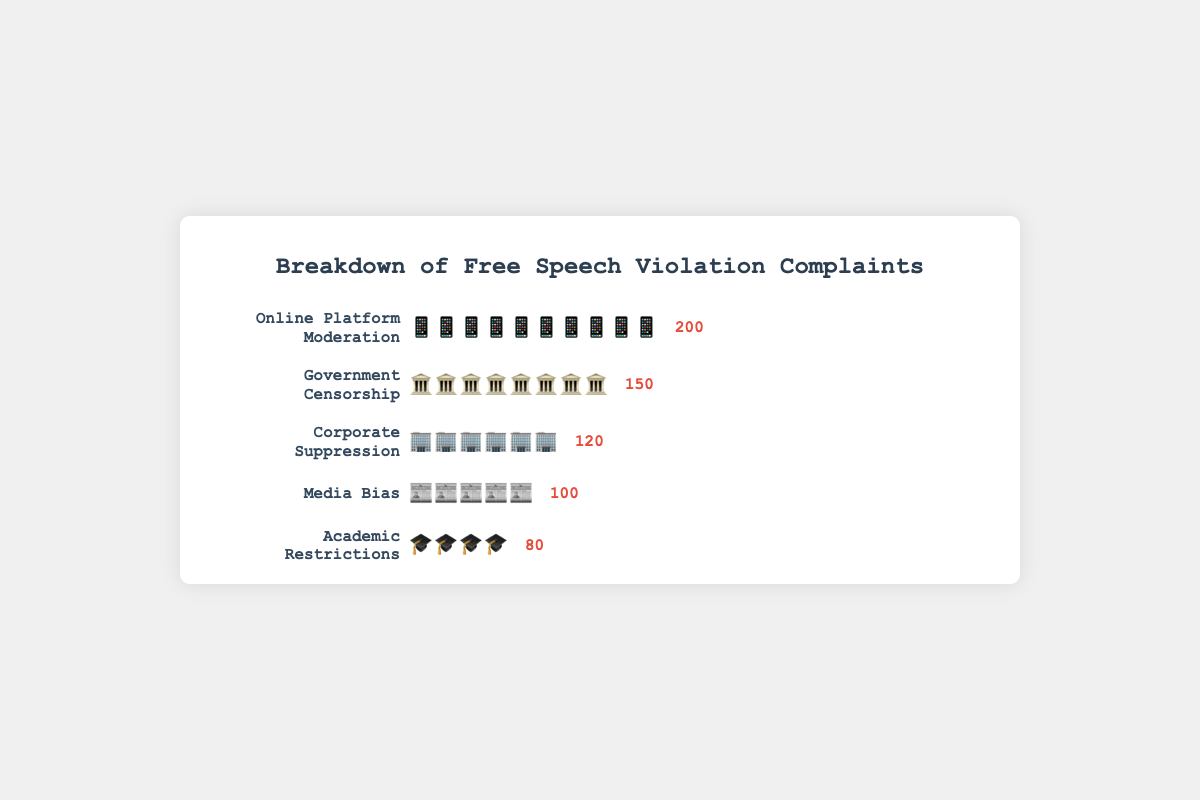Which category has the highest number of complaints? Look at the counts associated with each category. The highest number is 200, which corresponds to Online Platform Moderation
Answer: Online Platform Moderation How many more complaints are there about Government Censorship compared to Academic Restrictions? Subtract the number of complaints for Academic Restrictions (80) from the number of complaints for Government Censorship (150). The calculation is 150 - 80 = 70
Answer: 70 What is the total number of complaints across all categories? Add the complaint counts for all categories: 150 (Government Censorship) + 120 (Corporate Suppression) + 80 (Academic Restrictions) + 200 (Online Platform Moderation) + 100 (Media Bias). The calculation is 150 + 120 + 80 + 200 + 100 = 650
Answer: 650 Which category has the fewest complaints? Look at the counts associated with each category. The fewest number is 80, which corresponds to Academic Restrictions
Answer: Academic Restrictions What is the average number of complaints per category? Calculate the total number of complaints, 650, and divide it by the number of categories, 5. The calculation is 650 / 5 = 130
Answer: 130 How does the number of complaints about Corporate Suppression compare to Media Bias? Compare the counts: Corporate Suppression has 120 complaints, and Media Bias has 100 complaints. Therefore, Corporate Suppression has 20 more complaints.
Answer: 20 more complaints If the complaints are ranked by count, which category is third? Rank the categories by their counts: 1. Online Platform Moderation (200), 2. Government Censorship (150), 3. Corporate Suppression (120), 4. Media Bias (100), 5. Academic Restrictions (80). The third category is Corporate Suppression.
Answer: Corporate Suppression What is the difference in the number of complaints between the categories with the highest and the lowest counts? Subtract the number of complaints for Academic Restrictions (80) from the number of complaints for Online Platform Moderation (200). The calculation is 200 - 80 = 120
Answer: 120 Which two categories combined have the total number of complaints closest to 300? Add the number of complaints for various combinations to find the closest sum to 300: 
- Government Censorship + Corporate Suppression = 150 + 120 = 270
- Government Censorship + Academic Restrictions = 150 + 80 = 230
- Corporate Suppression + Academic Restrictions = 120 + 80 = 200
- Online Platform Moderation + Media Bias = 200 + 100 = 300
The closest combination giving exactly 300 is Online Platform Moderation and Media Bias
Answer: Online Platform Moderation and Media Bias 